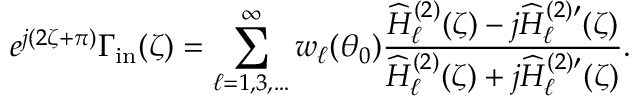Convert formula to latex. <formula><loc_0><loc_0><loc_500><loc_500>e ^ { j ( 2 \zeta + \pi ) } \Gamma _ { i n } ( \zeta ) = \sum _ { \ell = 1 , 3 , \dots } ^ { \infty } w _ { \ell } ( \theta _ { 0 } ) \frac { \widehat { H } _ { \ell } ^ { ( 2 ) } ( \zeta ) - j \widehat { H } _ { \ell } ^ { ( 2 ) \prime } ( \zeta ) } { \widehat { H } _ { \ell } ^ { ( 2 ) } ( \zeta ) + j \widehat { H } _ { \ell } ^ { ( 2 ) \prime } ( \zeta ) } .</formula> 